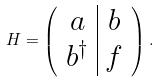Convert formula to latex. <formula><loc_0><loc_0><loc_500><loc_500>H = \left ( \begin{array} { c | c } a & b \\ b ^ { \dagger } & f \\ \end{array} \right ) .</formula> 